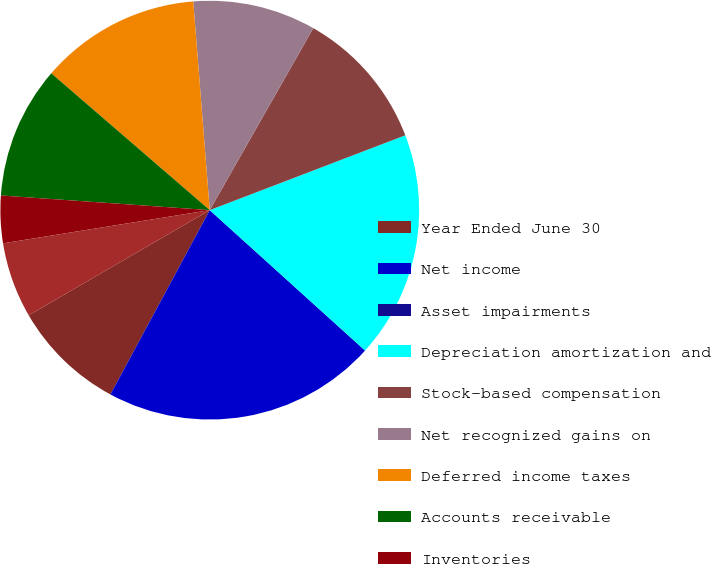Convert chart. <chart><loc_0><loc_0><loc_500><loc_500><pie_chart><fcel>Year Ended June 30<fcel>Net income<fcel>Asset impairments<fcel>Depreciation amortization and<fcel>Stock-based compensation<fcel>Net recognized gains on<fcel>Deferred income taxes<fcel>Accounts receivable<fcel>Inventories<fcel>Other current assets<nl><fcel>8.76%<fcel>21.17%<fcel>0.0%<fcel>17.52%<fcel>10.95%<fcel>9.49%<fcel>12.41%<fcel>10.22%<fcel>3.65%<fcel>5.84%<nl></chart> 